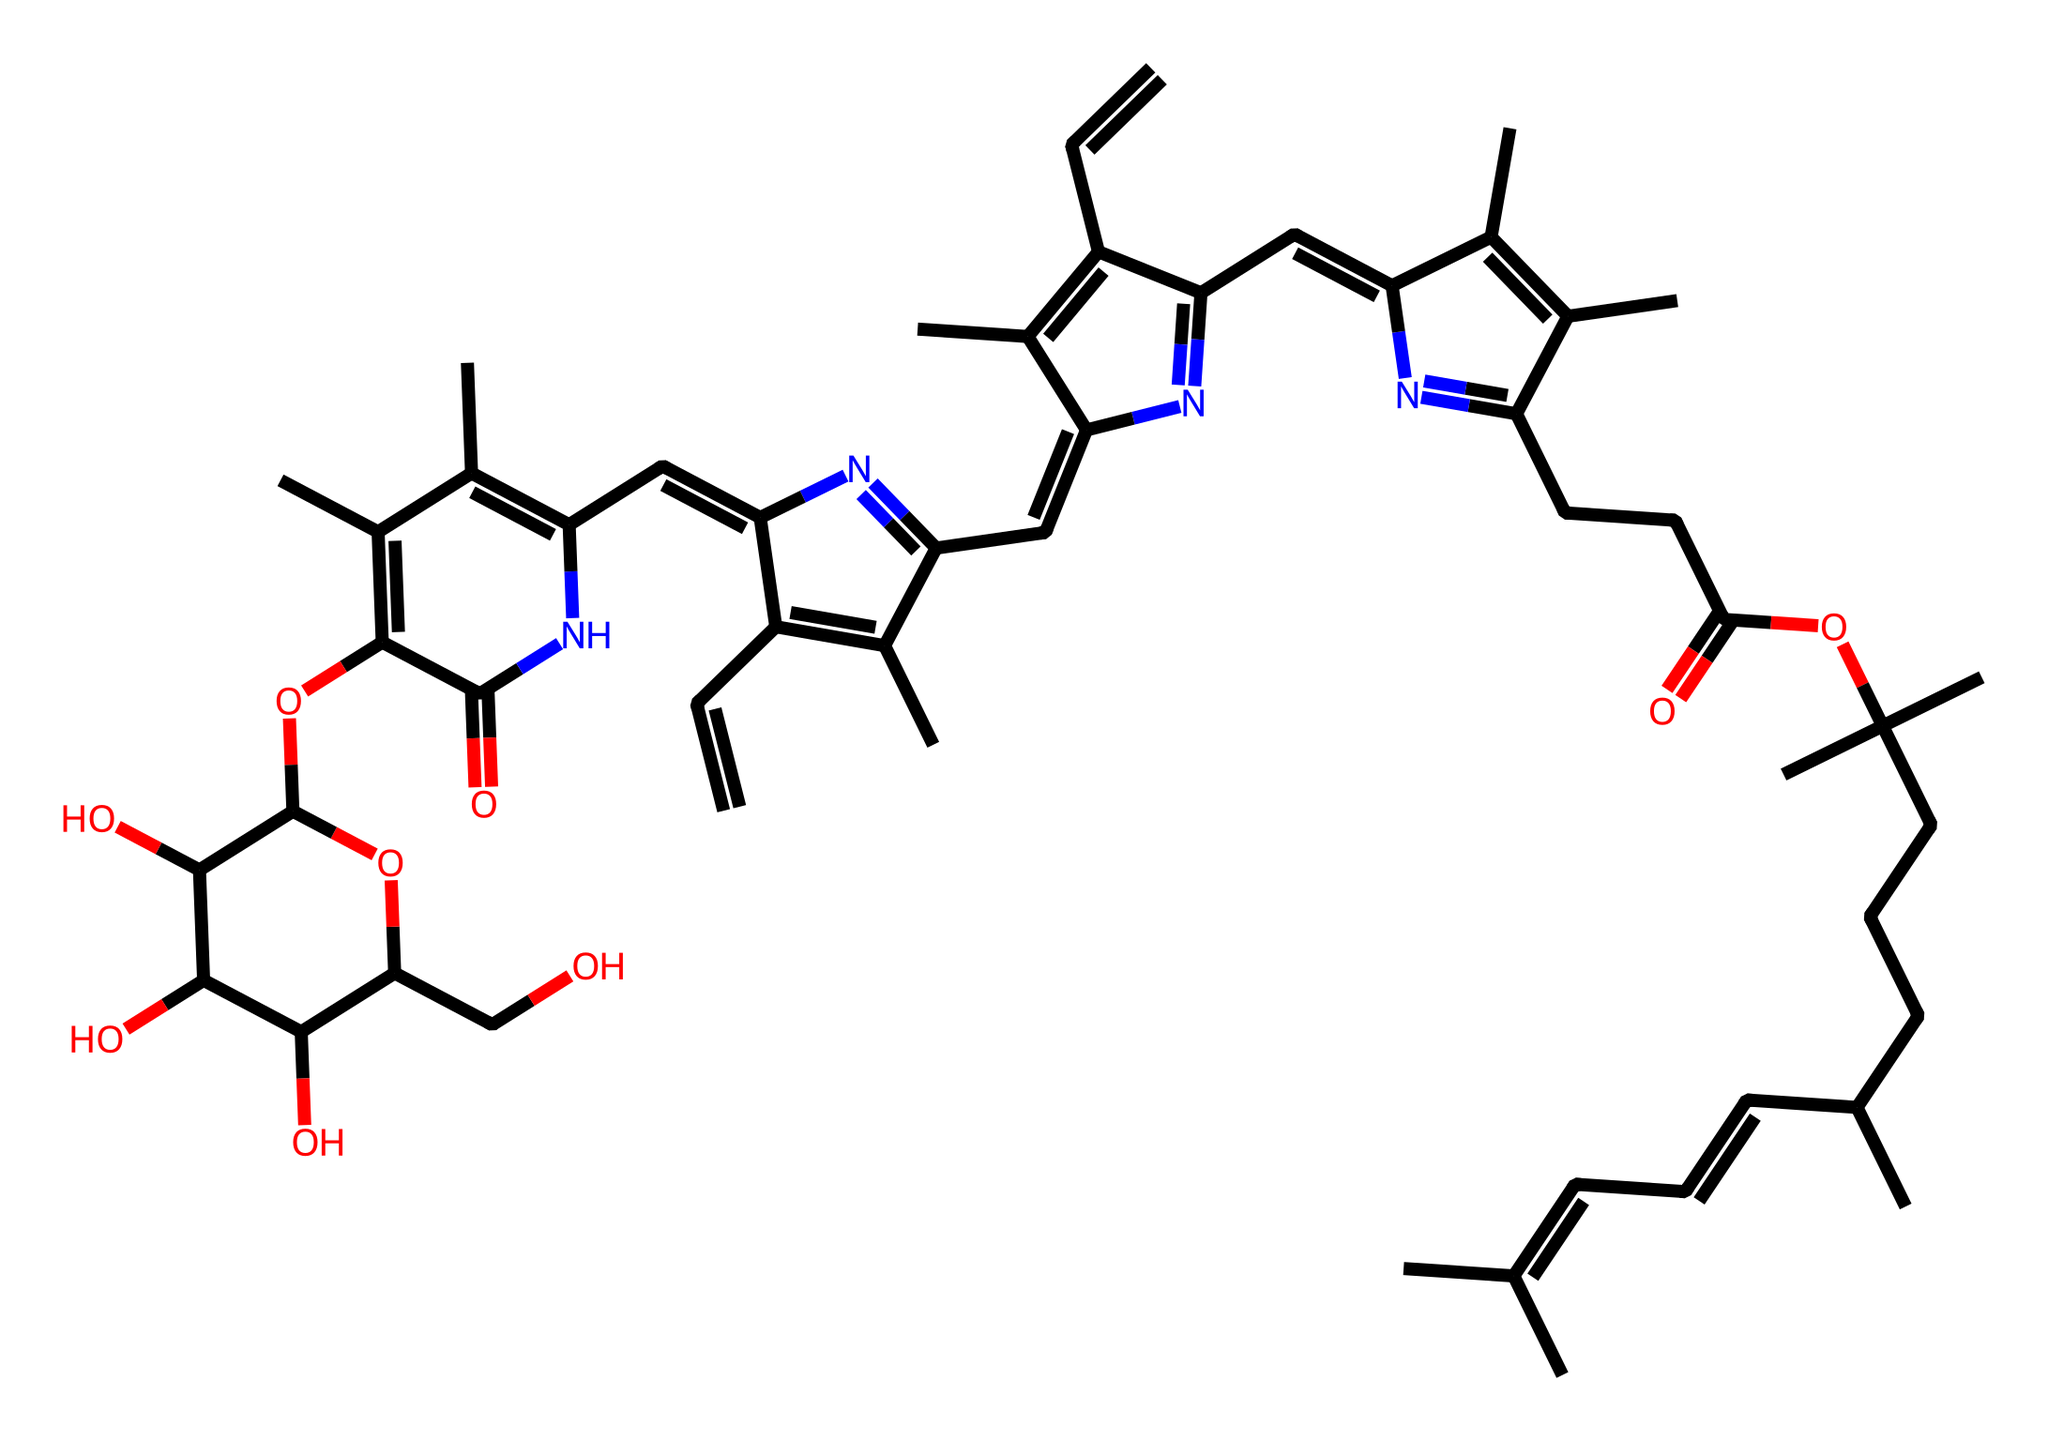What is the molecular formula of this chemical? The chemical structure can be analyzed to determine the number of each type of atom present. By counting the carbon (C), hydrogen (H), nitrogen (N), and oxygen (O) atoms in the structure, we derive the empirical formula C55H70N4O6.
Answer: C55H70N4O6 How many nitrogen atoms are present in the structure? By examining the structure, we can identify the nitrogen (N) atoms by counting how many times they appear. There are four nitrogen atoms visible in the structure, confirming their presence.
Answer: 4 What role does chlorophyll play in photosynthesis? Chlorophyll is a pigment crucial for capturing light energy from the sun, which is necessary for the process of photosynthesis. In plants, it absorbs light primarily for converting carbon dioxide and water into glucose and oxygen.
Answer: captures light energy Which functional groups are present in this molecule? A careful analysis of the structure reveals various functional groups, including carbonyls (C=O), amines (NH), and hydroxyls (OH). Identifying these groups informs us about the chemical's reactivity and role in biological systems.
Answer: carbonyls, amines, hydroxyls How does the structure of chlorophyll influence its color? The presence of conjugated double bonds in the chlorophyll structure allows it to absorb specific wavelengths of light, primarily red and blue, while reflecting green light, which is why chlorophyll appears green to our eyes.
Answer: conjugated double bonds What is the significance of the long hydrocarbon tail in chlorophyll? The long hydrocarbon tail increases the hydrophobic nature of chlorophyll, allowing it to embed in the thylakoid membrane of chloroplasts, which is essential for its role in photosynthesis.
Answer: increases hydrophobic nature 